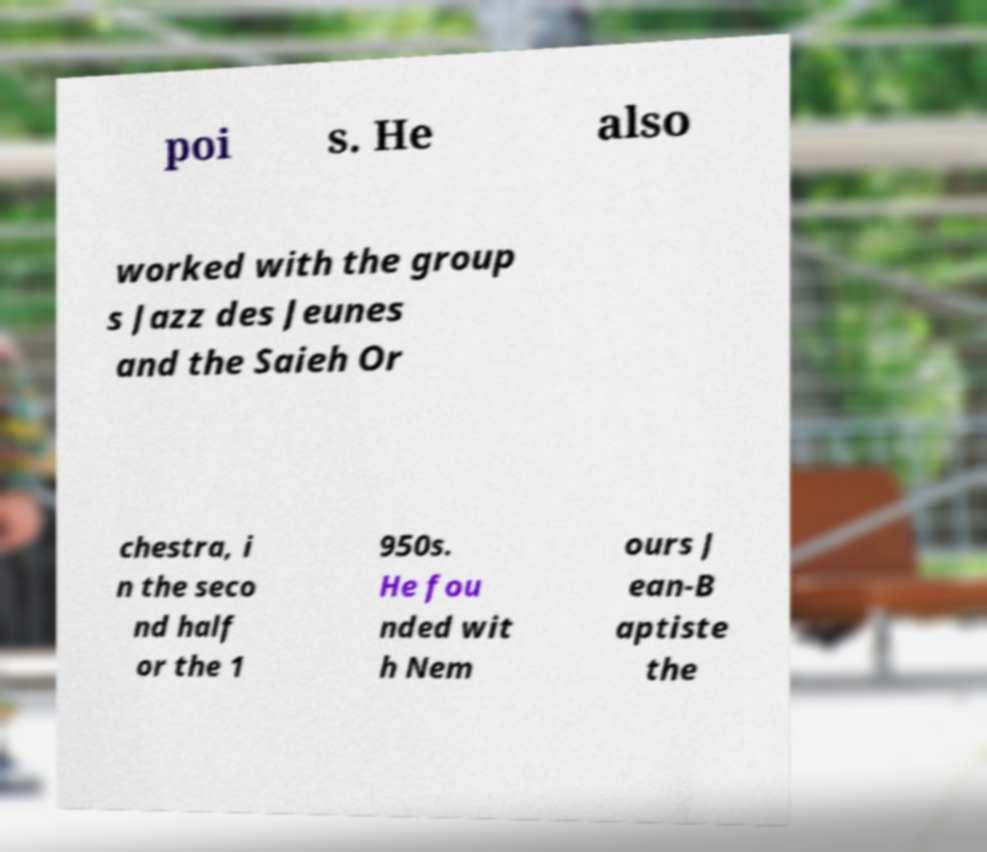Can you accurately transcribe the text from the provided image for me? poi s. He also worked with the group s Jazz des Jeunes and the Saieh Or chestra, i n the seco nd half or the 1 950s. He fou nded wit h Nem ours J ean-B aptiste the 